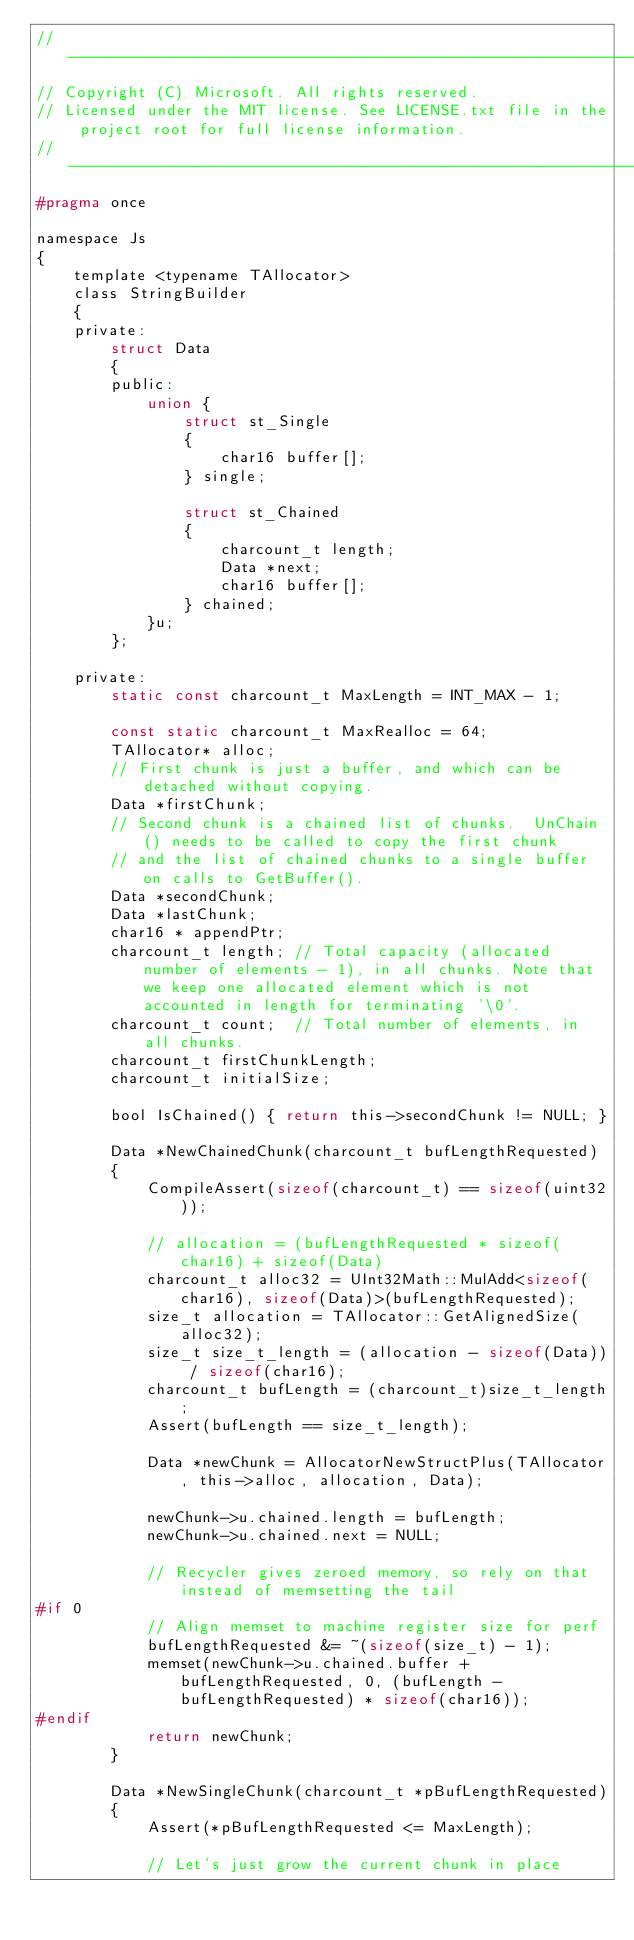<code> <loc_0><loc_0><loc_500><loc_500><_C_>//-------------------------------------------------------------------------------------------------------
// Copyright (C) Microsoft. All rights reserved.
// Licensed under the MIT license. See LICENSE.txt file in the project root for full license information.
//-------------------------------------------------------------------------------------------------------
#pragma once

namespace Js
{
    template <typename TAllocator>
    class StringBuilder
    {
    private:
        struct Data
        {
        public:
            union {
                struct st_Single
                {
                    char16 buffer[];
                } single;

                struct st_Chained
                {
                    charcount_t length;
                    Data *next;
                    char16 buffer[];
                } chained;
            }u;
        };

    private:
        static const charcount_t MaxLength = INT_MAX - 1;

        const static charcount_t MaxRealloc = 64;
        TAllocator* alloc;
        // First chunk is just a buffer, and which can be detached without copying.
        Data *firstChunk;
        // Second chunk is a chained list of chunks.  UnChain() needs to be called to copy the first chunk
        // and the list of chained chunks to a single buffer on calls to GetBuffer().
        Data *secondChunk;
        Data *lastChunk;
        char16 * appendPtr;
        charcount_t length; // Total capacity (allocated number of elements - 1), in all chunks. Note that we keep one allocated element which is not accounted in length for terminating '\0'.
        charcount_t count;  // Total number of elements, in all chunks.
        charcount_t firstChunkLength;
        charcount_t initialSize;

        bool IsChained() { return this->secondChunk != NULL; }

        Data *NewChainedChunk(charcount_t bufLengthRequested)
        {
            CompileAssert(sizeof(charcount_t) == sizeof(uint32));

            // allocation = (bufLengthRequested * sizeof(char16) + sizeof(Data)
            charcount_t alloc32 = UInt32Math::MulAdd<sizeof(char16), sizeof(Data)>(bufLengthRequested);
            size_t allocation = TAllocator::GetAlignedSize(alloc32);
            size_t size_t_length = (allocation - sizeof(Data)) / sizeof(char16);
            charcount_t bufLength = (charcount_t)size_t_length;
            Assert(bufLength == size_t_length);

            Data *newChunk = AllocatorNewStructPlus(TAllocator, this->alloc, allocation, Data);

            newChunk->u.chained.length = bufLength;
            newChunk->u.chained.next = NULL;

            // Recycler gives zeroed memory, so rely on that instead of memsetting the tail
#if 0
            // Align memset to machine register size for perf
            bufLengthRequested &= ~(sizeof(size_t) - 1);
            memset(newChunk->u.chained.buffer + bufLengthRequested, 0, (bufLength - bufLengthRequested) * sizeof(char16));
#endif
            return newChunk;
        }

        Data *NewSingleChunk(charcount_t *pBufLengthRequested)
        {
            Assert(*pBufLengthRequested <= MaxLength);

            // Let's just grow the current chunk in place
</code> 